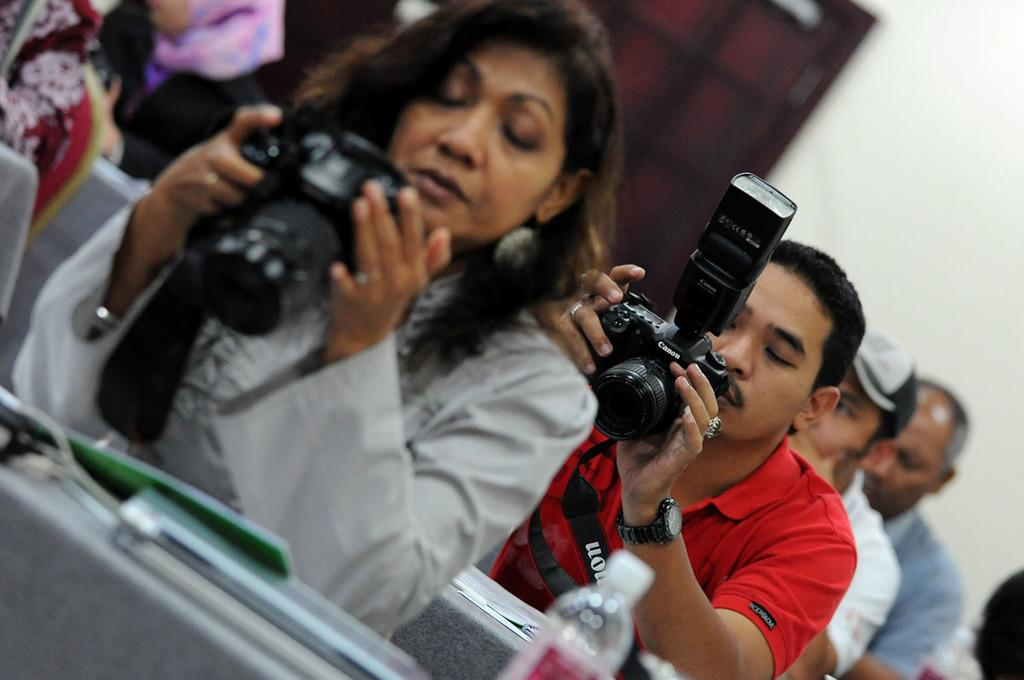Who is present in the image? There are people in the image. What are the people holding in their hands? The people are holding cameras in their hands. What are the people doing with the cameras? The people are looking at the cameras. What can be seen in the background of the image? There is a wall in the background of the image. What type of songs can be heard playing in the background of the image? There is no indication of any songs playing in the background of the image. 